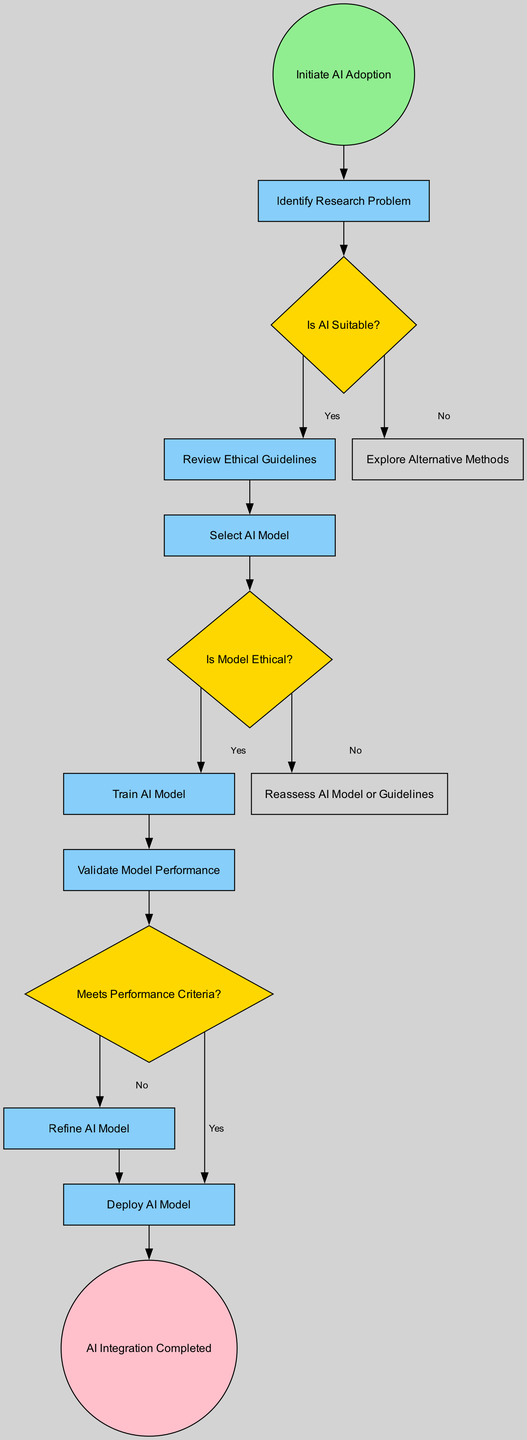What is the first action in the diagram? The diagram starts with the "Initiate AI Adoption" event, which is the first point in the workflow before any actions are taken.
Answer: Initiate AI Adoption How many decision nodes are present in the diagram? The diagram includes three decision nodes: "Is AI Suitable?", "Is Model Ethical?", and "Meets Performance Criteria?".
Answer: 3 What do you do if AI is not suitable for your research problem? If AI is determined to be unsuitable, the next action in the workflow is to "Explore Alternative Methods" according to the flow from the "Is AI Suitable?" decision node.
Answer: Explore Alternative Methods What happens if the model is ethical? Upon determining that the AI model is ethical from the "Is Model Ethical?" decision node, the next step is to "Train AI Model" before proceeding further in the workflow.
Answer: Train AI Model How many actions follow the decision "Meets Performance Criteria?" The decision "Meets Performance Criteria?" has two potential outcomes: if "Yes," you go to "Deploy AI Model," and if "No," you go to "Refine AI Model," indicating there are exactly two actions following this decision.
Answer: 2 What is the last event in this diagram? The final point in the workflow, marking the completion of the AI integration process, is labeled as "AI Integration Completed," which represents the endpoint of the activity diagram.
Answer: AI Integration Completed What action occurs immediately after "Review Ethical Guidelines"? Following the "Review Ethical Guidelines" action, the next step, based on the flow, is to "Select AI Model."
Answer: Select AI Model What is the outcome if the model does not meet the performance criteria? If the AI model fails to meet the performance criteria, the workflow directs to "Refine AI Model," indicating the necessity to improve the AI model before deployment.
Answer: Refine AI Model 